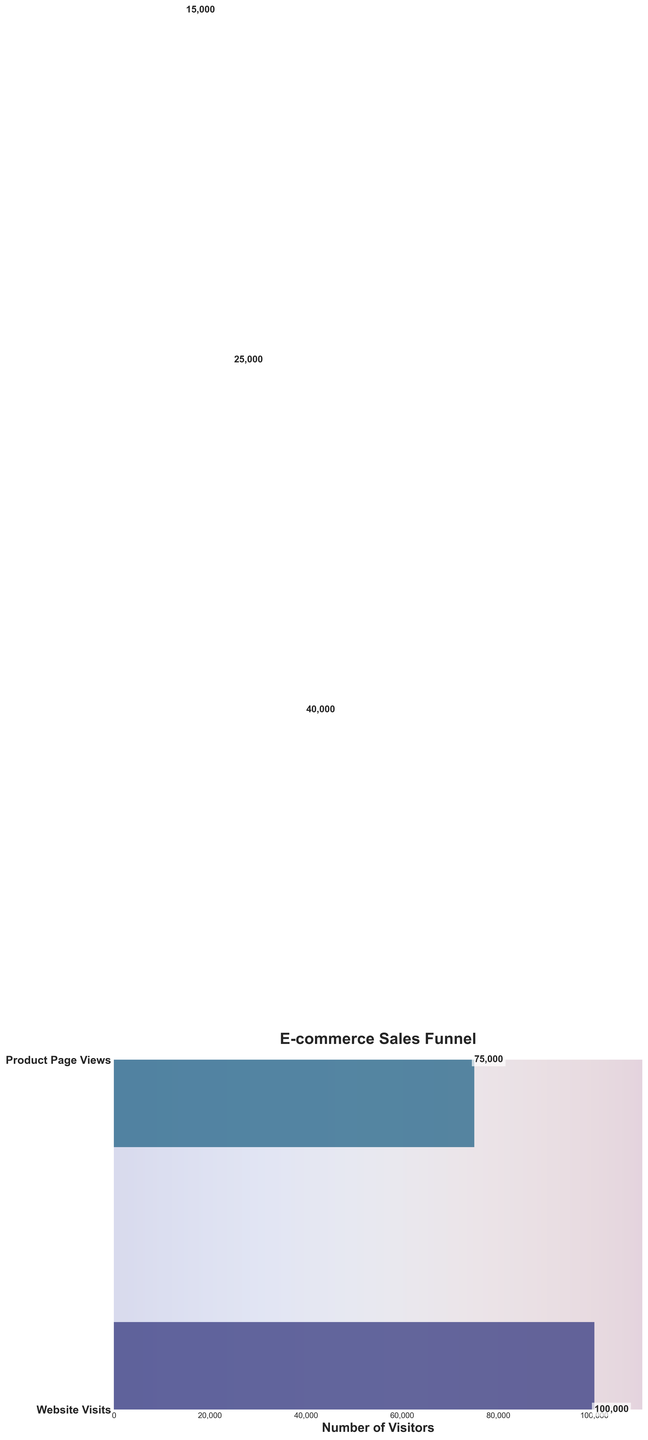What is the title of the figure? The title of the figure is displayed at the top and usually gives an overview of what the figure is about. In this case, the title is "E-commerce Sales Funnel."
Answer: E-commerce Sales Funnel How many stages are there in the sales funnel? Count the number of horizontal bars, each representing a stage. There are five stages: Website Visits, Product Page Views, Add to Cart, Initiated Checkout, and Completed Purchase.
Answer: 5 Which stage has the highest number of visitors? The stage with the longest horizontal bar represents the highest number of visitors. The "Website Visits" stage has the longest bar with 100,000 visitors.
Answer: Website Visits What is the number of visitors who added an item to the cart? Look for the "Add to Cart" stage in the figure and read the value labeled on the corresponding horizontal bar.
Answer: 40,000 What percentage of visitors who viewed the product page added an item to their cart? Calculate the percentage by dividing the number of visitors who added an item to their cart (40,000) by the number who viewed the product page (75,000), then multiply by 100: (40,000 / 75,000) * 100 ≈ 53.33%.
Answer: 53.33% How many visitors did not proceed from adding to the cart to initiating checkout? Subtract the number of visitors who initiated checkout (25,000) from those who added to the cart (40,000): 40,000 - 25,000 = 15,000.
Answer: 15,000 What is the conversion rate from website visits to completed purchases? Divide the number of completed purchases (15,000) by the number of website visits (100,000), and then multiply by 100: (15,000 / 100,000) * 100 = 15%.
Answer: 15% Which stage shows the highest drop-off in visitor numbers? The highest drop-off can be identified by the largest decrease between consecutive stages. "Product Page Views" to "Add to Cart" shows a drop-off from 75,000 to 40,000, a decrease of 35,000.
Answer: Product Page Views to Add to Cart How many more visitors started checkout than completed the purchase? Subtract the number of visitors who completed the purchase (15,000) from those who initiated checkout (25,000): 25,000 - 15,000 = 10,000.
Answer: 10,000 